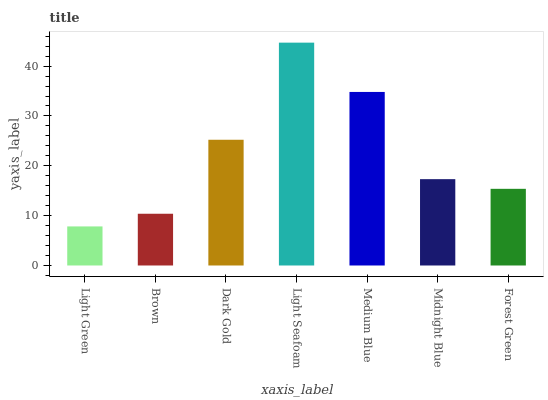Is Brown the minimum?
Answer yes or no. No. Is Brown the maximum?
Answer yes or no. No. Is Brown greater than Light Green?
Answer yes or no. Yes. Is Light Green less than Brown?
Answer yes or no. Yes. Is Light Green greater than Brown?
Answer yes or no. No. Is Brown less than Light Green?
Answer yes or no. No. Is Midnight Blue the high median?
Answer yes or no. Yes. Is Midnight Blue the low median?
Answer yes or no. Yes. Is Light Green the high median?
Answer yes or no. No. Is Brown the low median?
Answer yes or no. No. 